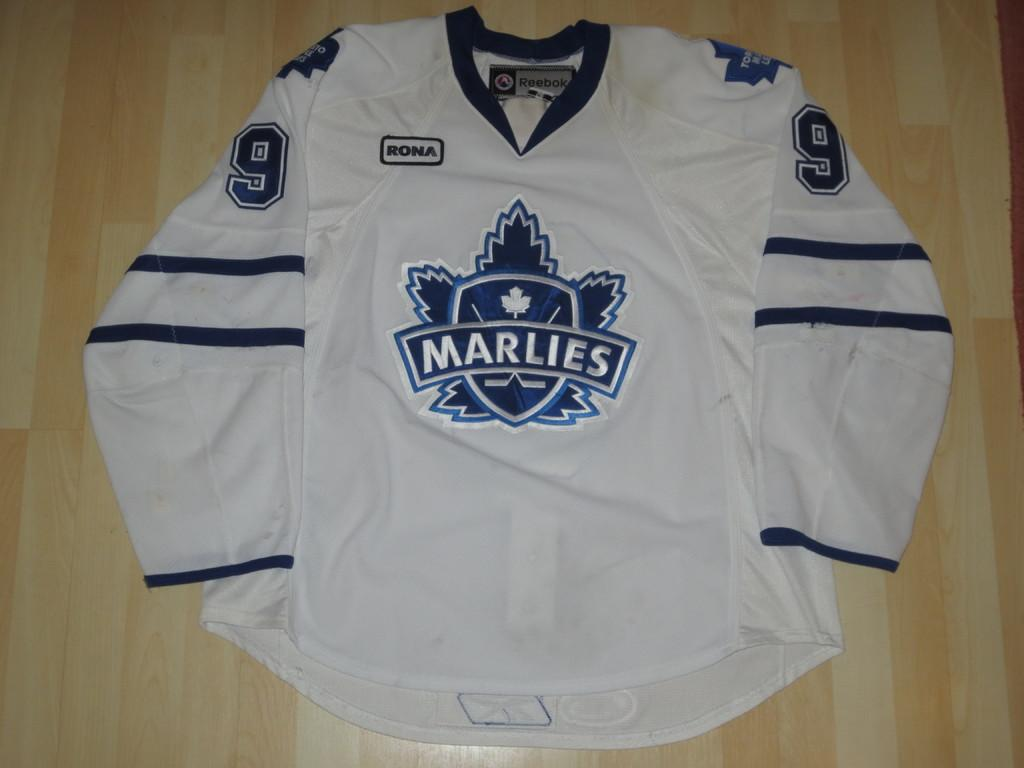<image>
Offer a succinct explanation of the picture presented. the Marlies number 9 jersey is on the floor 